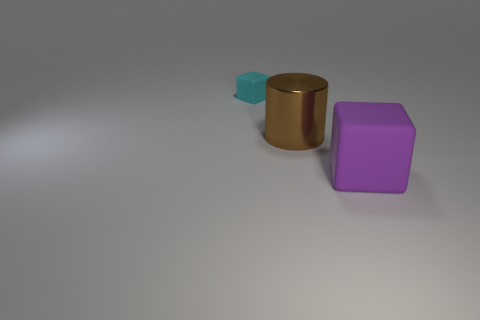Subtract all purple blocks. Subtract all yellow spheres. How many blocks are left? 1 Add 1 brown metallic spheres. How many objects exist? 4 Subtract all large brown metallic cylinders. Subtract all purple matte things. How many objects are left? 1 Add 3 brown metal cylinders. How many brown metal cylinders are left? 4 Add 2 large things. How many large things exist? 4 Subtract 0 blue cylinders. How many objects are left? 3 Subtract all blocks. How many objects are left? 1 